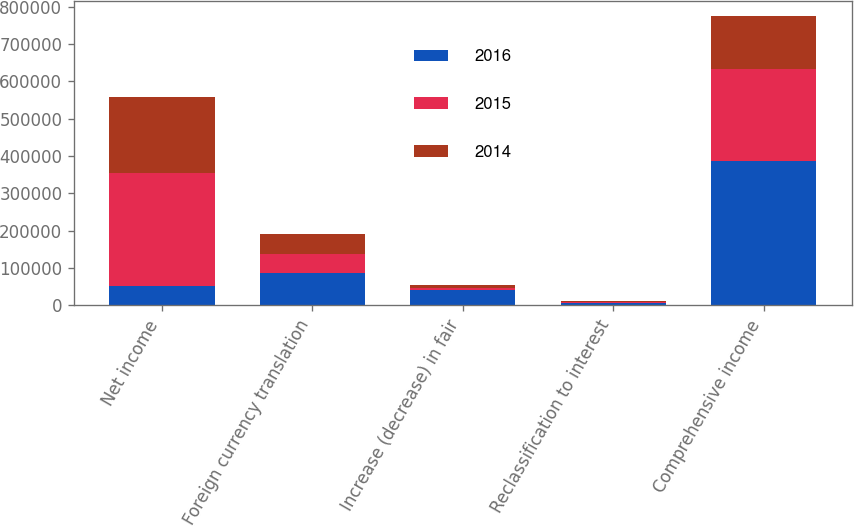<chart> <loc_0><loc_0><loc_500><loc_500><stacked_bar_chart><ecel><fcel>Net income<fcel>Foreign currency translation<fcel>Increase (decrease) in fair<fcel>Reclassification to interest<fcel>Comprehensive income<nl><fcel>2016<fcel>52059<fcel>86621<fcel>41998<fcel>4968<fcel>387172<nl><fcel>2015<fcel>301591<fcel>51745<fcel>3407<fcel>2621<fcel>245145<nl><fcel>2014<fcel>203415<fcel>52373<fcel>7936<fcel>3419<fcel>144446<nl></chart> 